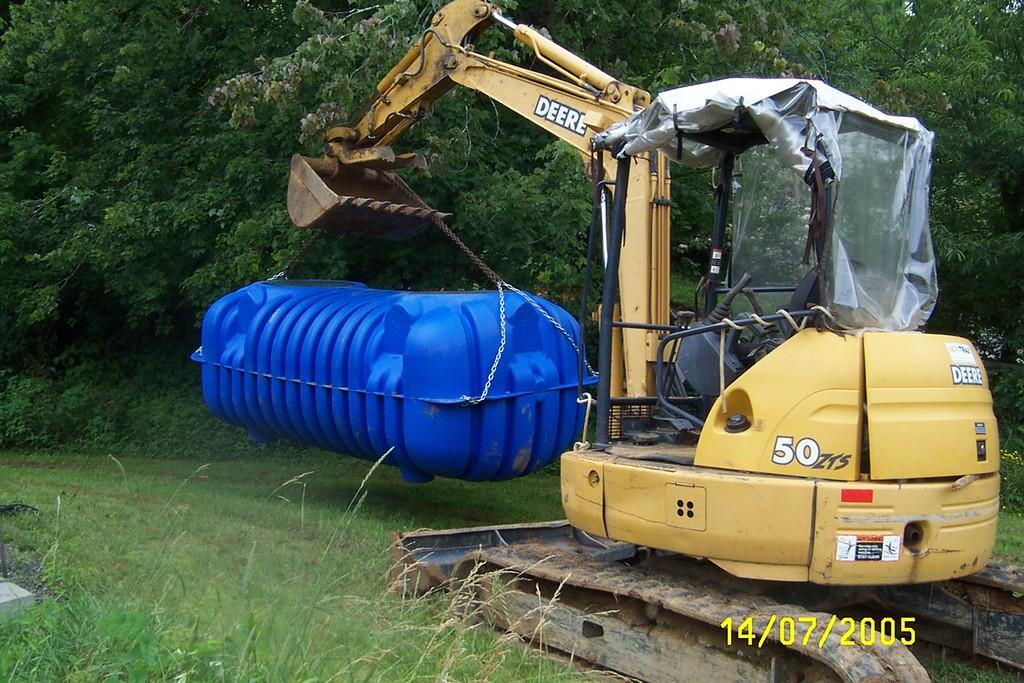What color is the crane in the image? The crane in the image is yellow. Where is the crane located in the image? The crane is on the ground. What is the crane doing in the image? The crane is lifting a large blue box. What type of vegetation is present on the ground in the image? There is grass on the ground. What can be seen in the background of the image? There are trees in the background of the image. What is the rate at which the zinc is being transported by the crane in the image? There is no zinc present in the image, and therefore no rate of transportation can be determined. 